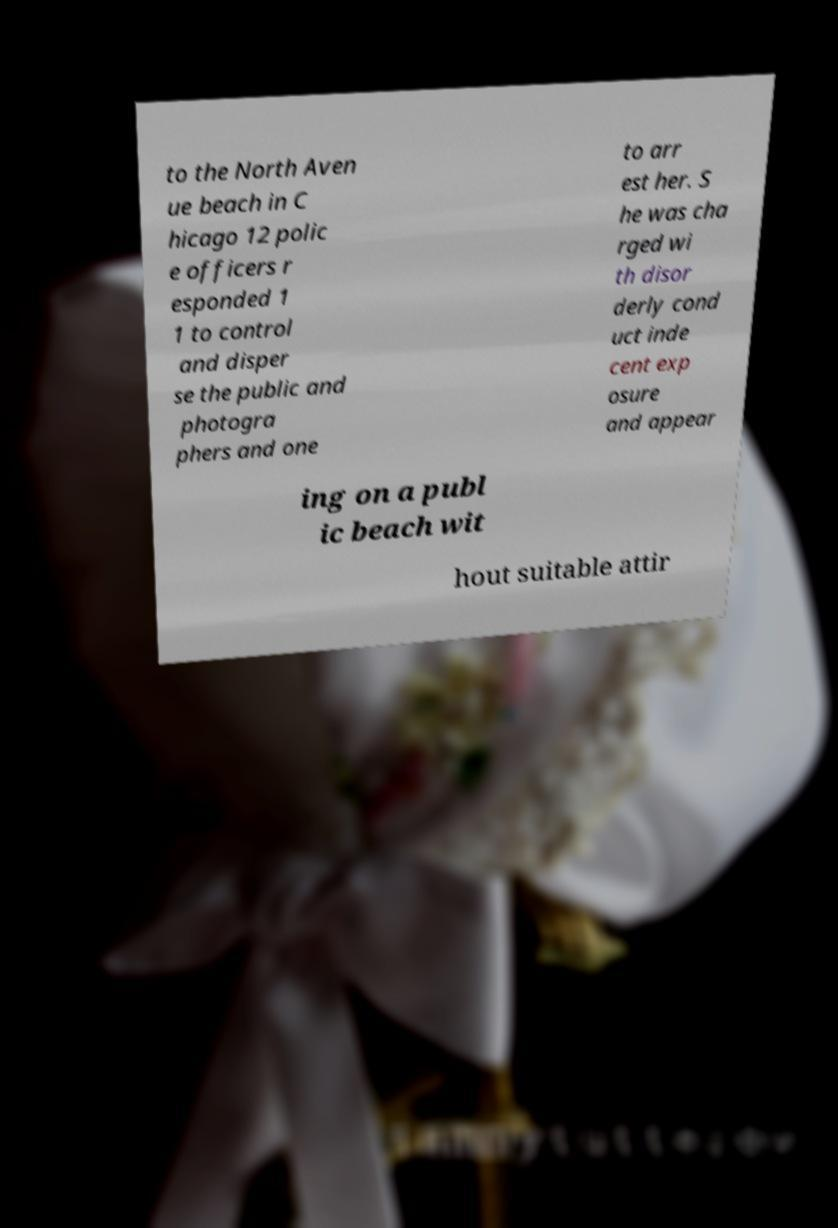I need the written content from this picture converted into text. Can you do that? to the North Aven ue beach in C hicago 12 polic e officers r esponded 1 1 to control and disper se the public and photogra phers and one to arr est her. S he was cha rged wi th disor derly cond uct inde cent exp osure and appear ing on a publ ic beach wit hout suitable attir 